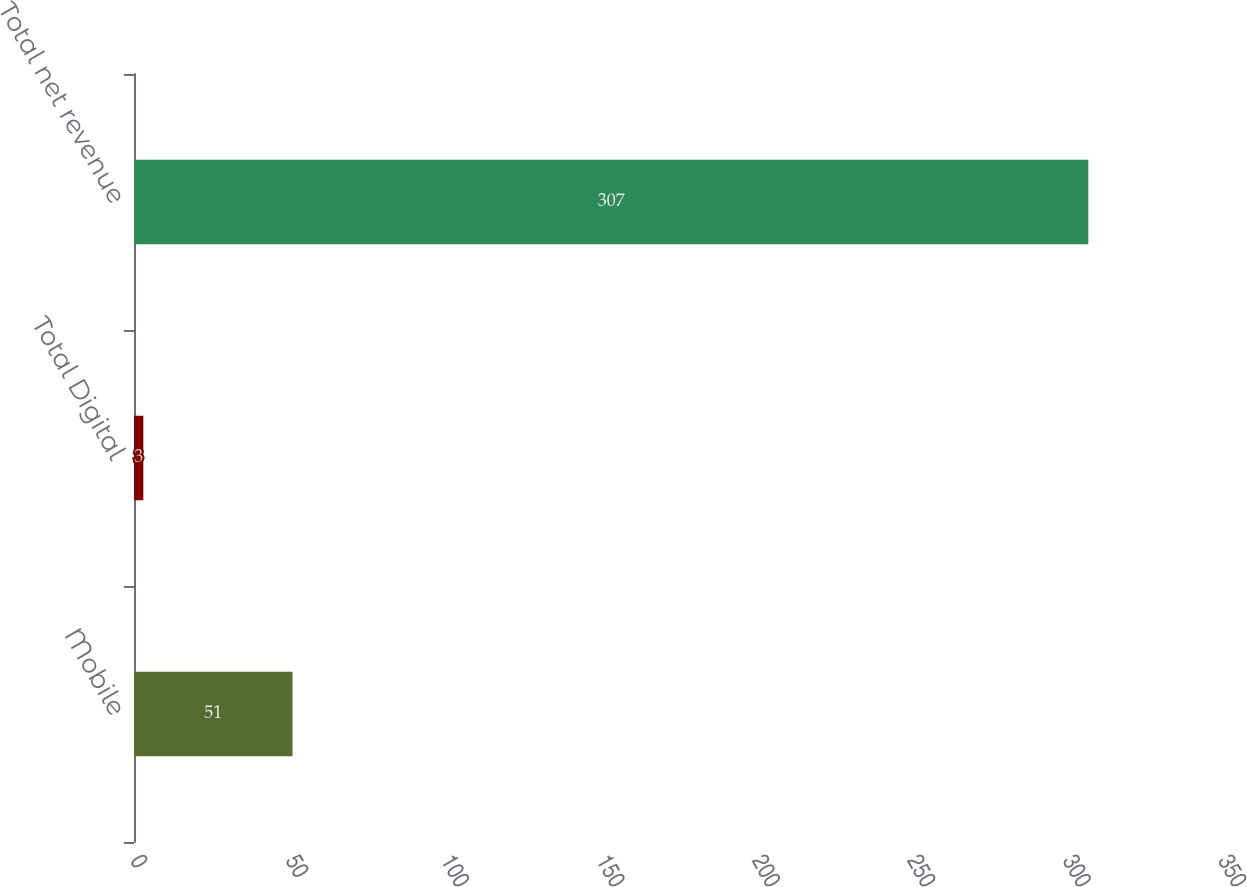Convert chart. <chart><loc_0><loc_0><loc_500><loc_500><bar_chart><fcel>Mobile<fcel>Total Digital<fcel>Total net revenue<nl><fcel>51<fcel>3<fcel>307<nl></chart> 